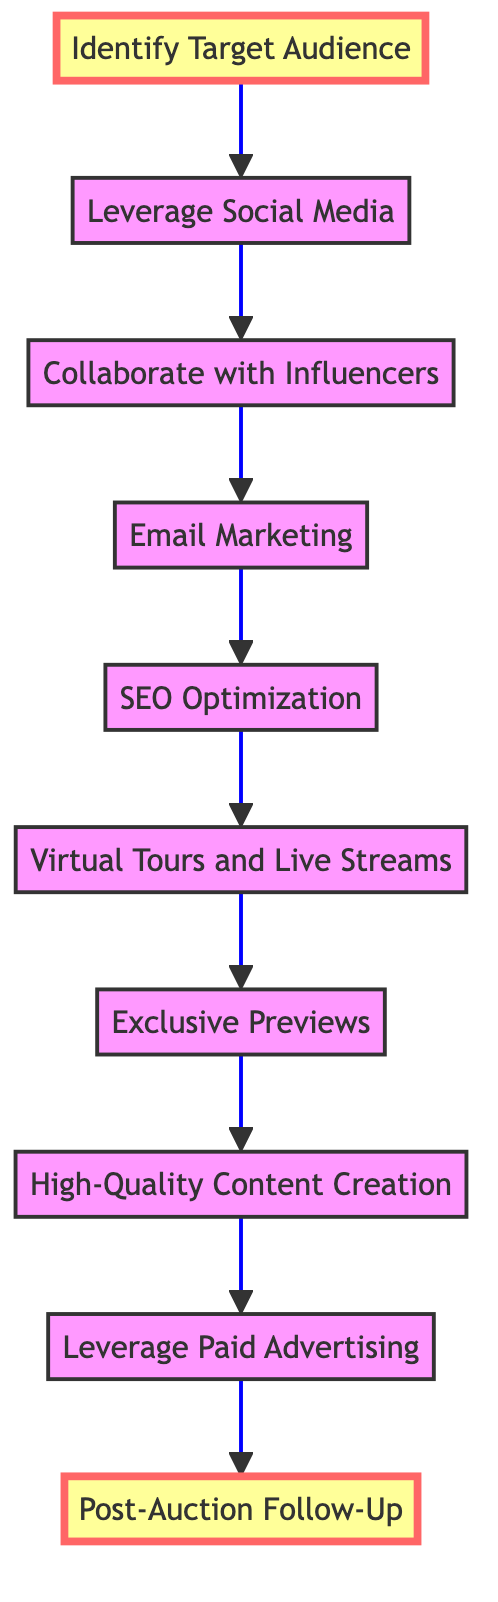What is the starting point of the flow chart? The first node in the flow chart is "Identify Target Audience," which serves as the starting point for the marketing strategies.
Answer: Identify Target Audience How many nodes are in the diagram? The diagram features a total of ten nodes, each representing different marketing strategies.
Answer: 10 What is the last step in the marketing process according to the diagram? The final step in the flow chart is "Post-Auction Follow-Up," which highlights the importance of building relationships after the auction.
Answer: Post-Auction Follow-Up Which two nodes are directly connected by an edge after "Leverage Social Media"? After "Leverage Social Media," the next directly connected node is "Collaborate with Influencers." This connection indicates the progression from social media engagement to influencer marketing.
Answer: Collaborate with Influencers What is the primary function of the node "Exclusive Previews"? The node "Exclusive Previews" is focused on organizing invite-only events for clients to experience supercars in person, providing an exclusive opportunity to potential buyers.
Answer: Organize invite-only events What is the relationship between "SEO Optimization" and "Virtual Tours and Live Streams"? "SEO Optimization" leads to "Virtual Tours and Live Streams," indicating that improving search engine rankings can enhance online engagement through virtual experiences.
Answer: Leading to Virtual Tours and Live Streams How does one proceed from "High-Quality Content Creation"? After "High-Quality Content Creation," the next step is "Leverage Paid Advertising," showing that high-quality content is essential for effective advertising.
Answer: Leverage Paid Advertising What marketing strategy does the flow chart suggest follows "Email Marketing"? The flow chart suggests that "SEO Optimization" follows "Email Marketing," indicating a systematic approach to improve reach and awareness.
Answer: SEO Optimization What is the purpose of the strategy linked to "Leverage Paid Advertising"? The strategy linked to "Leverage Paid Advertising" aims to target specific audiences effectively through platforms like Google Ads and Facebook Ads, maximizing reach.
Answer: Target specific audiences 